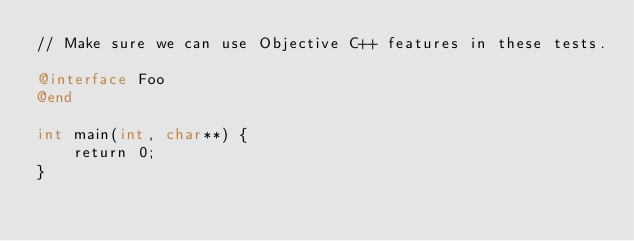Convert code to text. <code><loc_0><loc_0><loc_500><loc_500><_ObjectiveC_>// Make sure we can use Objective C++ features in these tests.

@interface Foo
@end

int main(int, char**) {
    return 0;
}
</code> 